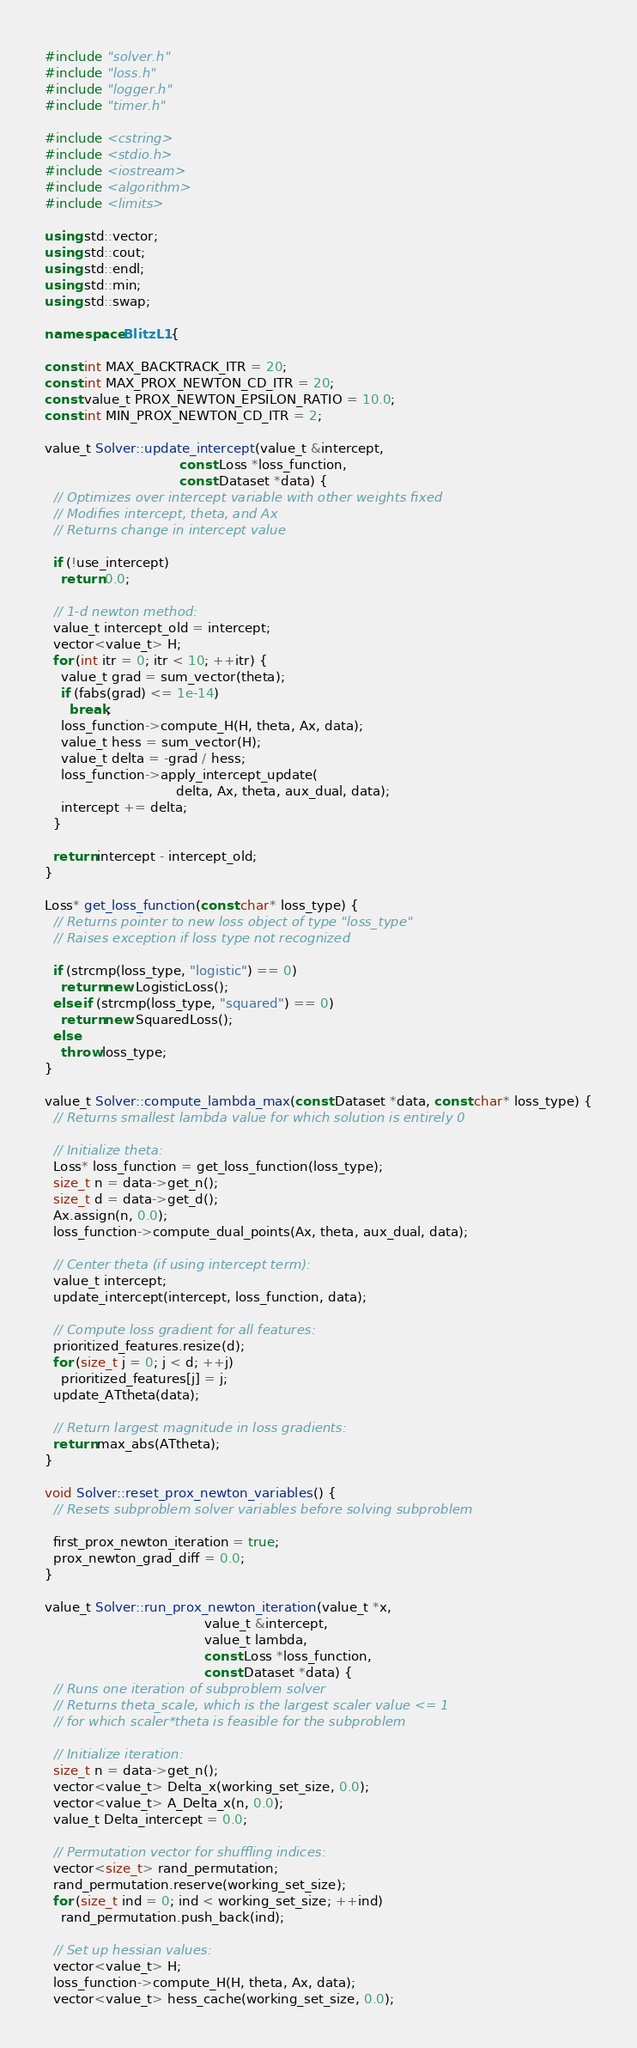<code> <loc_0><loc_0><loc_500><loc_500><_C++_>#include "solver.h"
#include "loss.h"
#include "logger.h"
#include "timer.h"

#include <cstring>
#include <stdio.h>
#include <iostream>
#include <algorithm>
#include <limits>

using std::vector;
using std::cout;
using std::endl;
using std::min;
using std::swap;

namespace BlitzL1 {

const int MAX_BACKTRACK_ITR = 20;
const int MAX_PROX_NEWTON_CD_ITR = 20;
const value_t PROX_NEWTON_EPSILON_RATIO = 10.0;
const int MIN_PROX_NEWTON_CD_ITR = 2;

value_t Solver::update_intercept(value_t &intercept, 
                                 const Loss *loss_function,
                                 const Dataset *data) {
  // Optimizes over intercept variable with other weights fixed
  // Modifies intercept, theta, and Ax
  // Returns change in intercept value

  if (!use_intercept)
    return 0.0;

  // 1-d newton method:
  value_t intercept_old = intercept;
  vector<value_t> H;
  for (int itr = 0; itr < 10; ++itr) {
    value_t grad = sum_vector(theta);
    if (fabs(grad) <= 1e-14)
      break;
    loss_function->compute_H(H, theta, Ax, data);
    value_t hess = sum_vector(H);
    value_t delta = -grad / hess;
    loss_function->apply_intercept_update(
                                delta, Ax, theta, aux_dual, data);
    intercept += delta;
  }

  return intercept - intercept_old;
}

Loss* get_loss_function(const char* loss_type) {
  // Returns pointer to new loss object of type "loss_type"
  // Raises exception if loss type not recognized

  if (strcmp(loss_type, "logistic") == 0)
    return new LogisticLoss();
  else if (strcmp(loss_type, "squared") == 0)
    return new SquaredLoss();
  else
    throw loss_type;
}

value_t Solver::compute_lambda_max(const Dataset *data, const char* loss_type) {
  // Returns smallest lambda value for which solution is entirely 0

  // Initialize theta:
  Loss* loss_function = get_loss_function(loss_type);    
  size_t n = data->get_n();
  size_t d = data->get_d();
  Ax.assign(n, 0.0);
  loss_function->compute_dual_points(Ax, theta, aux_dual, data);

  // Center theta (if using intercept term):
  value_t intercept;
  update_intercept(intercept, loss_function, data);

  // Compute loss gradient for all features:
  prioritized_features.resize(d);
  for (size_t j = 0; j < d; ++j)
    prioritized_features[j] = j;
  update_ATtheta(data);

  // Return largest magnitude in loss gradients:
  return max_abs(ATtheta);
}

void Solver::reset_prox_newton_variables() {
  // Resets subproblem solver variables before solving subproblem

  first_prox_newton_iteration = true;
  prox_newton_grad_diff = 0.0;
}

value_t Solver::run_prox_newton_iteration(value_t *x, 
                                       value_t &intercept, 
                                       value_t lambda,
                                       const Loss *loss_function, 
                                       const Dataset *data) {
  // Runs one iteration of subproblem solver
  // Returns theta_scale, which is the largest scaler value <= 1
  // for which scaler*theta is feasible for the subproblem

  // Initialize iteration:
  size_t n = data->get_n();
  vector<value_t> Delta_x(working_set_size, 0.0);
  vector<value_t> A_Delta_x(n, 0.0);
  value_t Delta_intercept = 0.0;

  // Permutation vector for shuffling indices:
  vector<size_t> rand_permutation;
  rand_permutation.reserve(working_set_size);
  for (size_t ind = 0; ind < working_set_size; ++ind)
    rand_permutation.push_back(ind);

  // Set up hessian values:
  vector<value_t> H;
  loss_function->compute_H(H, theta, Ax, data);
  vector<value_t> hess_cache(working_set_size, 0.0);</code> 